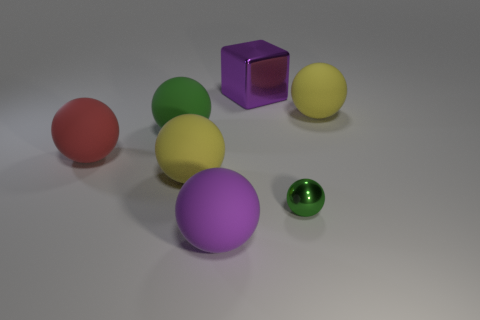Are there fewer small purple shiny cylinders than purple rubber balls?
Offer a terse response. Yes. Is there a large green object that is to the right of the large rubber ball that is in front of the small metallic ball?
Your answer should be very brief. No. Is there a purple metallic object that is in front of the big yellow sphere to the right of the big rubber ball that is in front of the tiny green metal sphere?
Give a very brief answer. No. There is a purple thing behind the purple rubber sphere; does it have the same shape as the large rubber thing on the left side of the green rubber ball?
Offer a very short reply. No. There is a sphere that is made of the same material as the big purple cube; what color is it?
Your response must be concise. Green. Are there fewer blocks that are to the left of the big purple metallic thing than objects?
Your answer should be compact. Yes. There is a yellow rubber object that is behind the big yellow matte thing that is on the left side of the big matte ball that is on the right side of the block; what is its size?
Provide a succinct answer. Large. Do the big yellow thing that is on the left side of the purple block and the purple ball have the same material?
Make the answer very short. Yes. What is the material of the large thing that is the same color as the tiny sphere?
Ensure brevity in your answer.  Rubber. Are there any other things that have the same shape as the big red rubber thing?
Provide a succinct answer. Yes. 